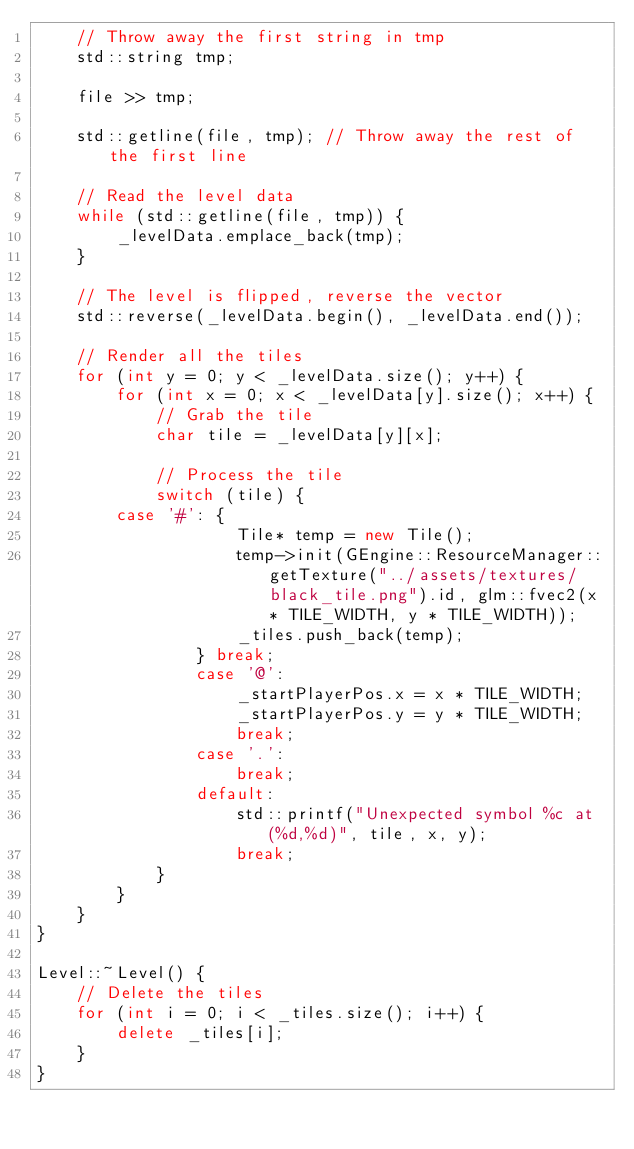Convert code to text. <code><loc_0><loc_0><loc_500><loc_500><_C++_>    // Throw away the first string in tmp
    std::string tmp;

    file >> tmp;

    std::getline(file, tmp); // Throw away the rest of the first line

    // Read the level data
    while (std::getline(file, tmp)) {
        _levelData.emplace_back(tmp);
    }    
    
    // The level is flipped, reverse the vector
    std::reverse(_levelData.begin(), _levelData.end());

    // Render all the tiles
    for (int y = 0; y < _levelData.size(); y++) {
        for (int x = 0; x < _levelData[y].size(); x++) {
            // Grab the tile
            char tile = _levelData[y][x];

            // Process the tile
            switch (tile) {
				case '#': {
                    Tile* temp = new Tile();
                    temp->init(GEngine::ResourceManager::getTexture("../assets/textures/black_tile.png").id, glm::fvec2(x * TILE_WIDTH, y * TILE_WIDTH));
                    _tiles.push_back(temp);
                } break;
                case '@':
                    _startPlayerPos.x = x * TILE_WIDTH;
                    _startPlayerPos.y = y * TILE_WIDTH;
                    break;
                case '.':
                    break;
                default:
                    std::printf("Unexpected symbol %c at (%d,%d)", tile, x, y);
                    break;
            }
        }
    }
}

Level::~Level() {
    // Delete the tiles
    for (int i = 0; i < _tiles.size(); i++) {
        delete _tiles[i];
    }
}
</code> 